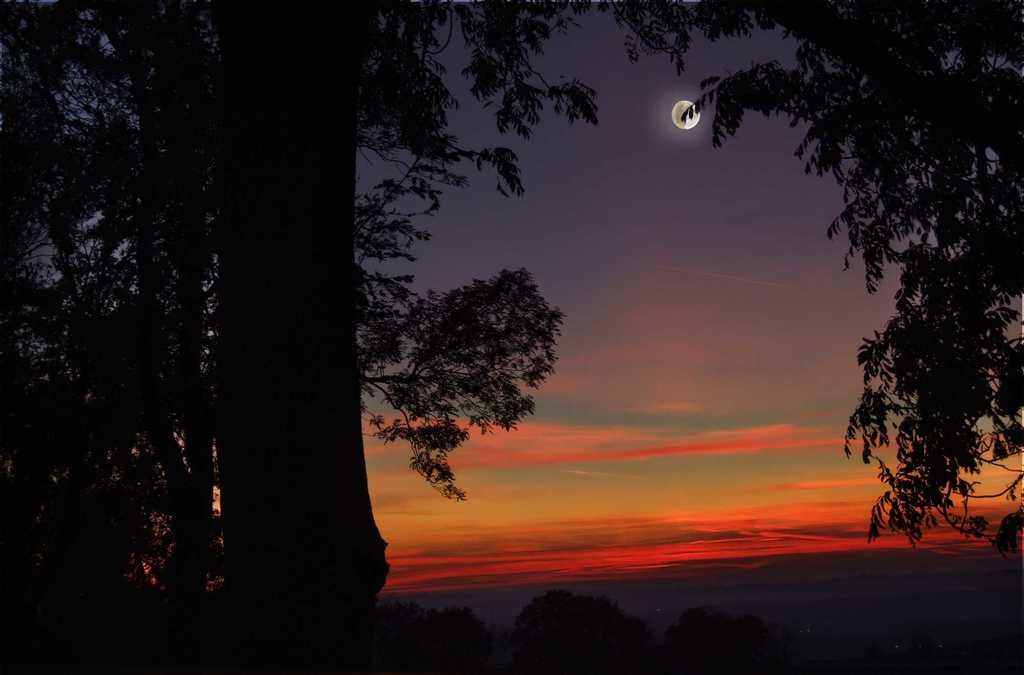What type of vegetation can be seen in the image? There are trees in the image. What celestial body is visible in the sky? There is a moon visible in the sky. How many bears are climbing the trees in the image? There are no bears present in the image; it features trees and a moon in the sky. What type of glove is hanging from the tree in the image? There is no glove present in the image; it only features trees and a moon in the sky. 